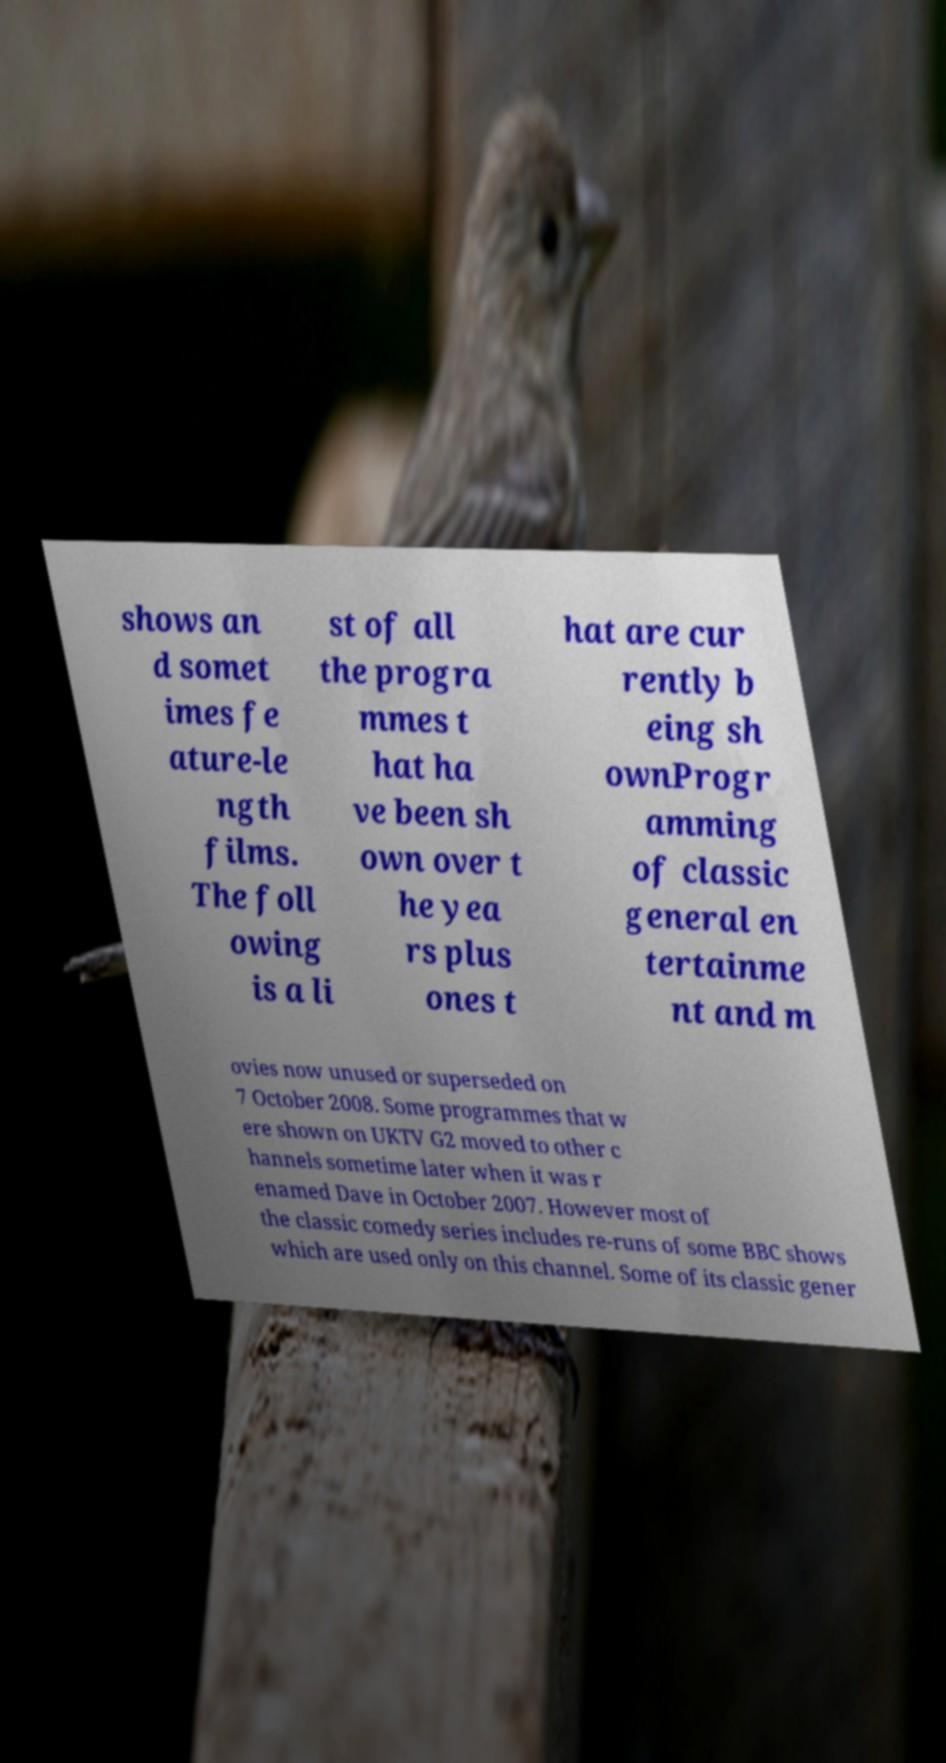Could you assist in decoding the text presented in this image and type it out clearly? shows an d somet imes fe ature-le ngth films. The foll owing is a li st of all the progra mmes t hat ha ve been sh own over t he yea rs plus ones t hat are cur rently b eing sh ownProgr amming of classic general en tertainme nt and m ovies now unused or superseded on 7 October 2008. Some programmes that w ere shown on UKTV G2 moved to other c hannels sometime later when it was r enamed Dave in October 2007. However most of the classic comedy series includes re-runs of some BBC shows which are used only on this channel. Some of its classic gener 